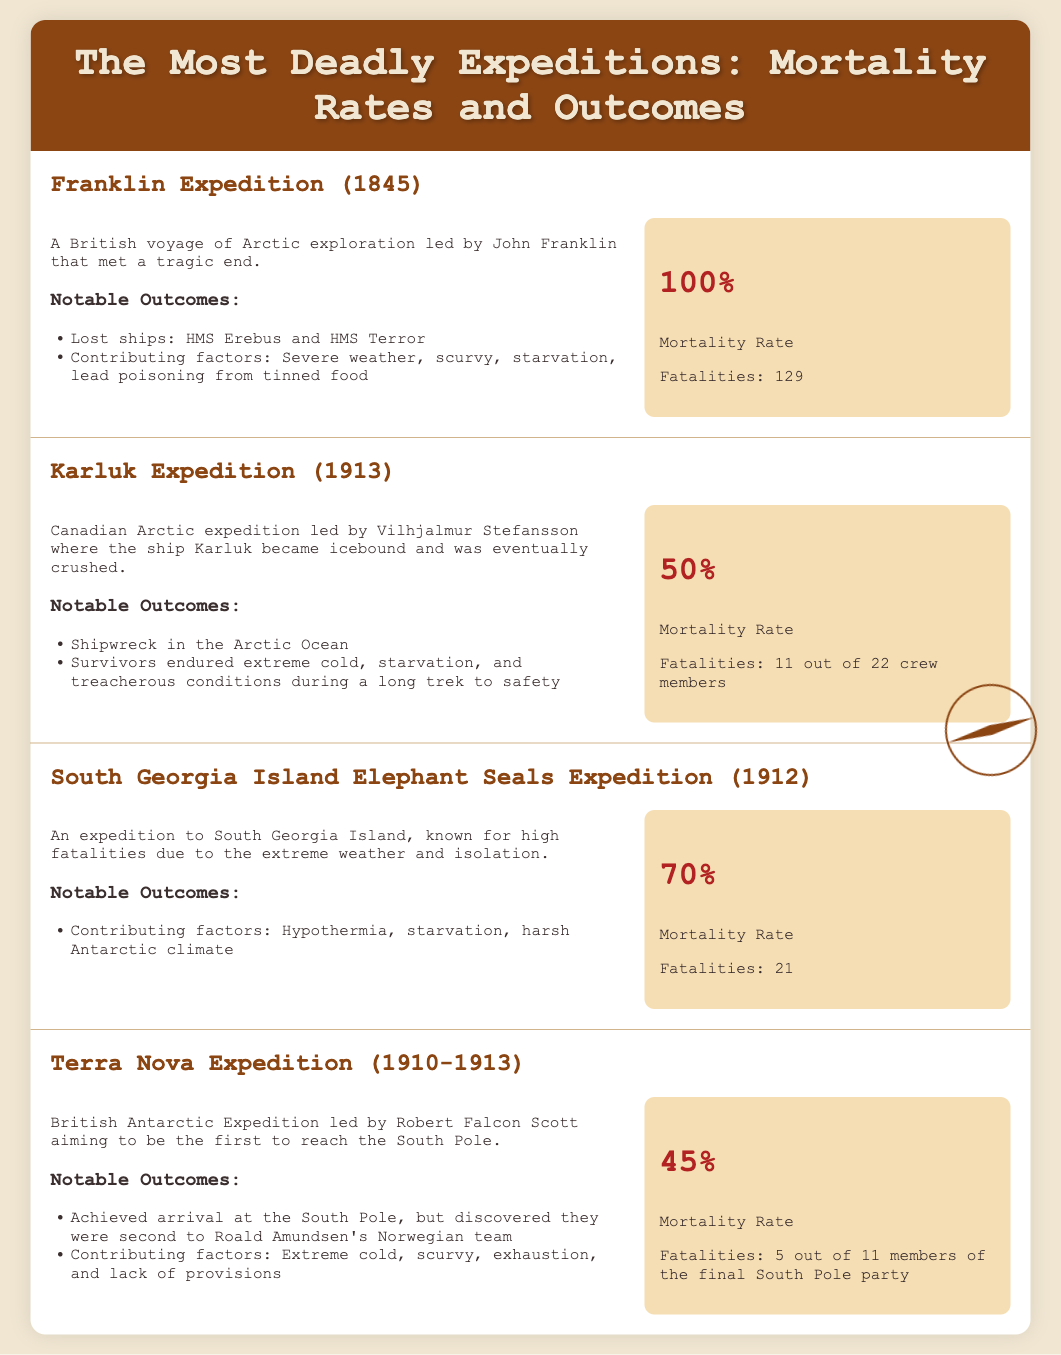What was the mortality rate of the Franklin Expedition? The document states a mortality rate of 100% for the Franklin Expedition.
Answer: 100% How many fatalities occurred in the Karluk Expedition? According to the document, there were 11 fatalities out of 22 crew members in the Karluk Expedition.
Answer: 11 What year did the South Georgia Island Elephant Seals Expedition take place? The document indicates that the South Georgia Island Elephant Seals Expedition was in the year 1912.
Answer: 1912 What contributed to the failures in the Terra Nova Expedition? The document lists extreme cold, scurvy, exhaustion, and lack of provisions as contributing factors to the failures in the Terra Nova Expedition.
Answer: Extreme cold, scurvy, exhaustion, lack of provisions How many crew members survived the Karluk Expedition? The document states that out of 22 crew members, 11 did not survive, which means 11 survived.
Answer: 11 